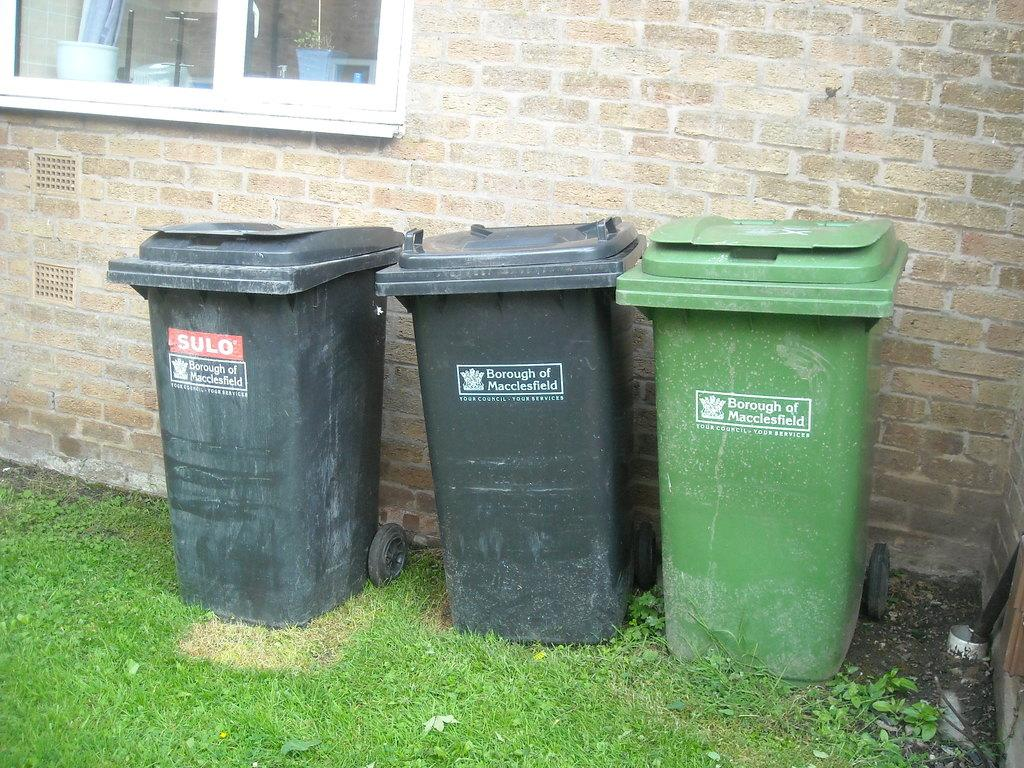<image>
Write a terse but informative summary of the picture. garbage cans with the words Borough of Macclesfield 